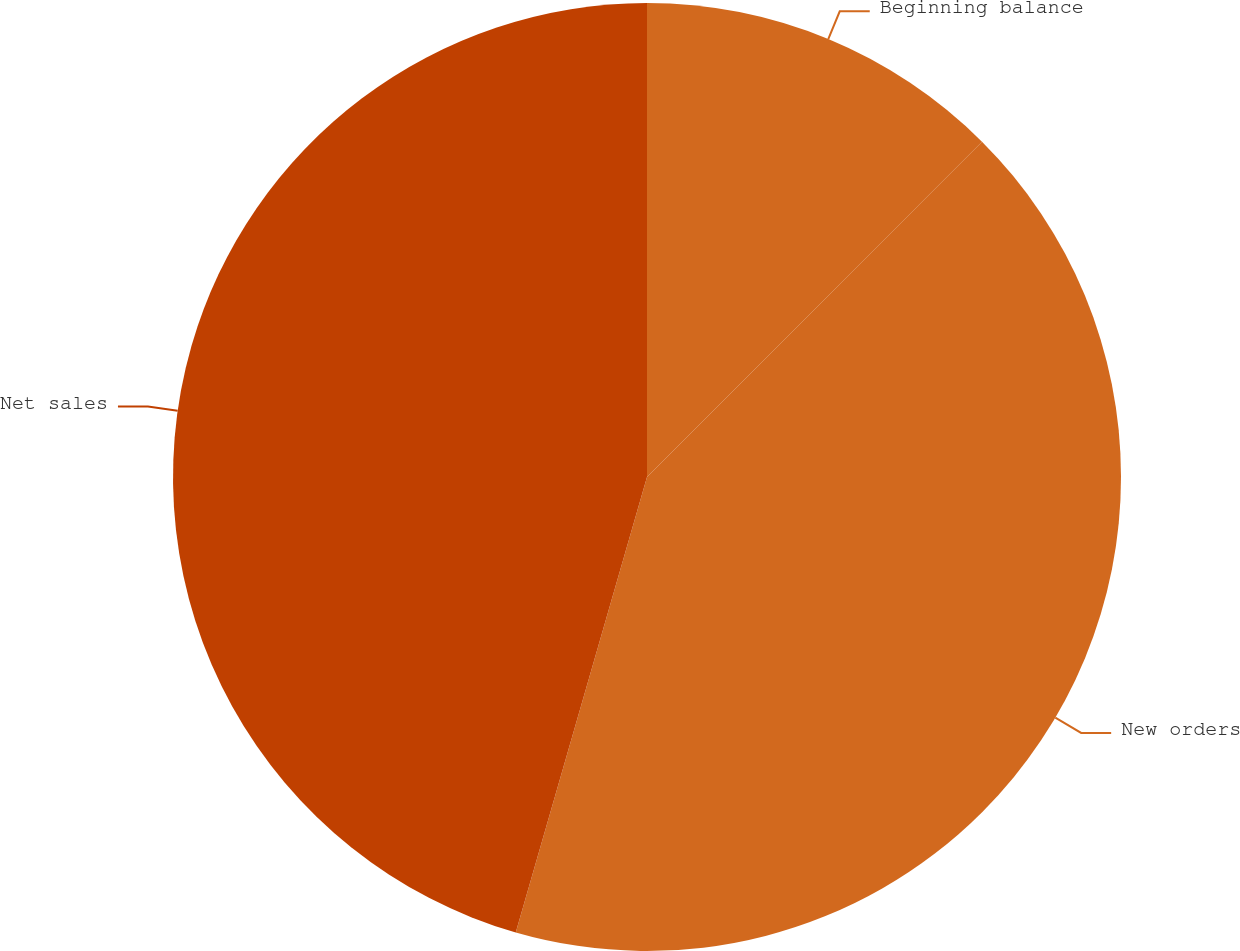Convert chart to OTSL. <chart><loc_0><loc_0><loc_500><loc_500><pie_chart><fcel>Beginning balance<fcel>New orders<fcel>Net sales<nl><fcel>12.49%<fcel>41.97%<fcel>45.53%<nl></chart> 